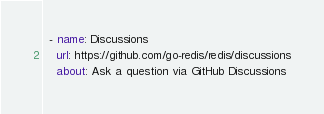Convert code to text. <code><loc_0><loc_0><loc_500><loc_500><_YAML_>  - name: Discussions
    url: https://github.com/go-redis/redis/discussions
    about: Ask a question via GitHub Discussions
</code> 